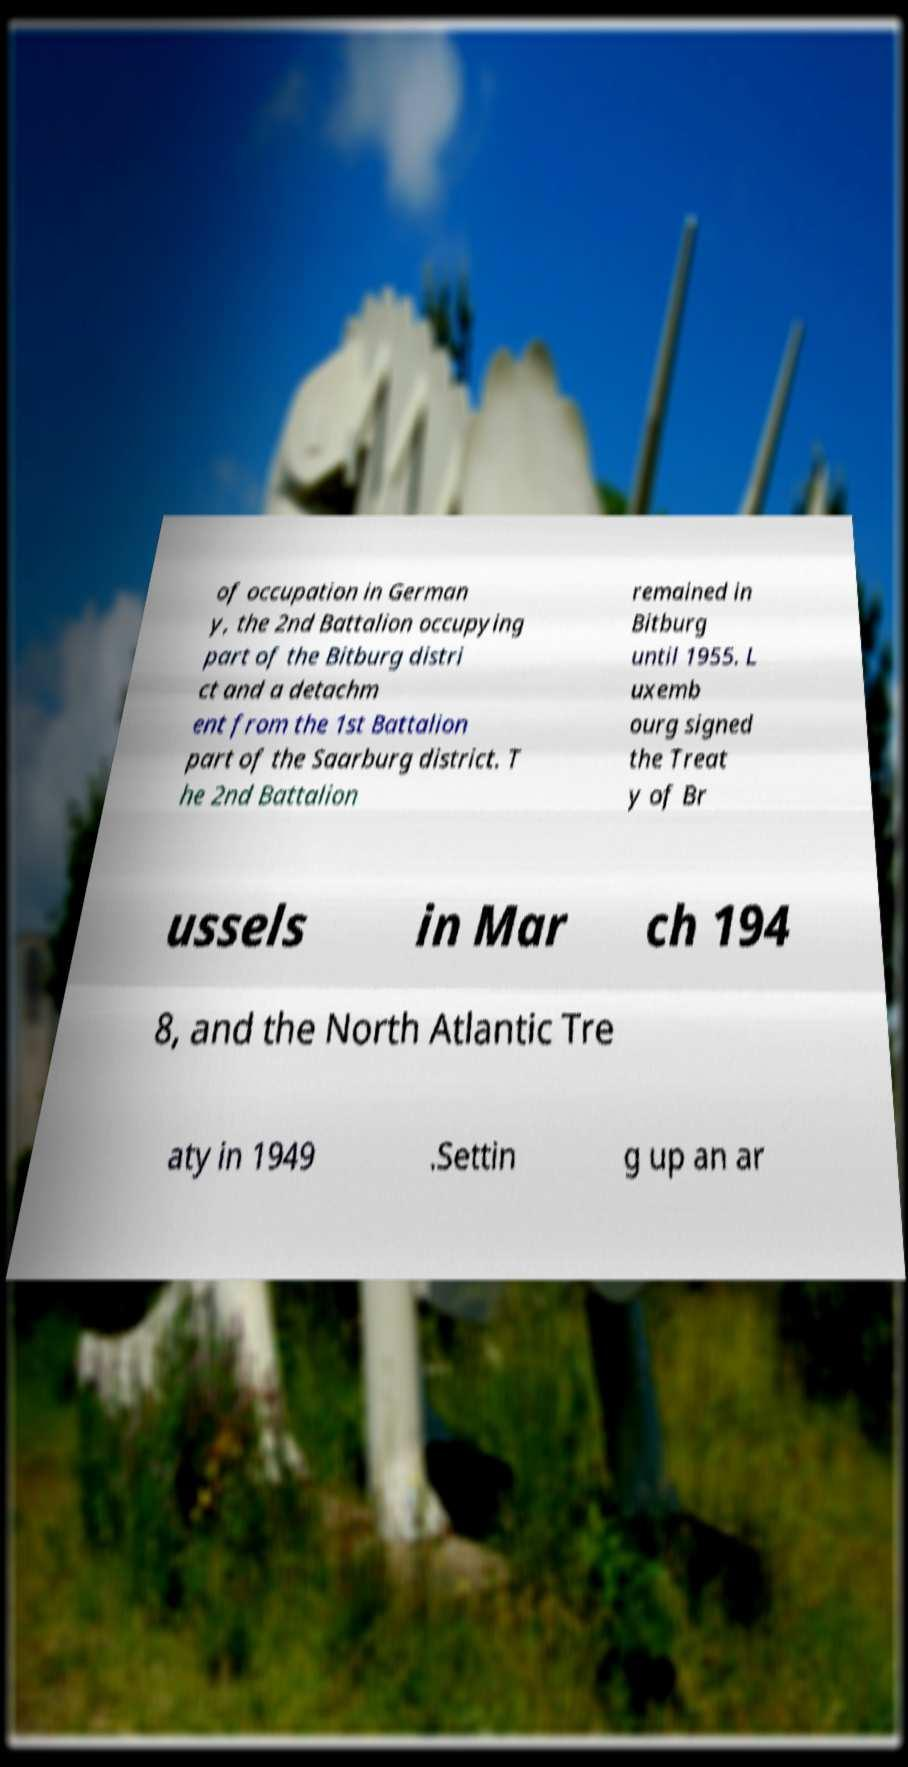Can you accurately transcribe the text from the provided image for me? of occupation in German y, the 2nd Battalion occupying part of the Bitburg distri ct and a detachm ent from the 1st Battalion part of the Saarburg district. T he 2nd Battalion remained in Bitburg until 1955. L uxemb ourg signed the Treat y of Br ussels in Mar ch 194 8, and the North Atlantic Tre aty in 1949 .Settin g up an ar 